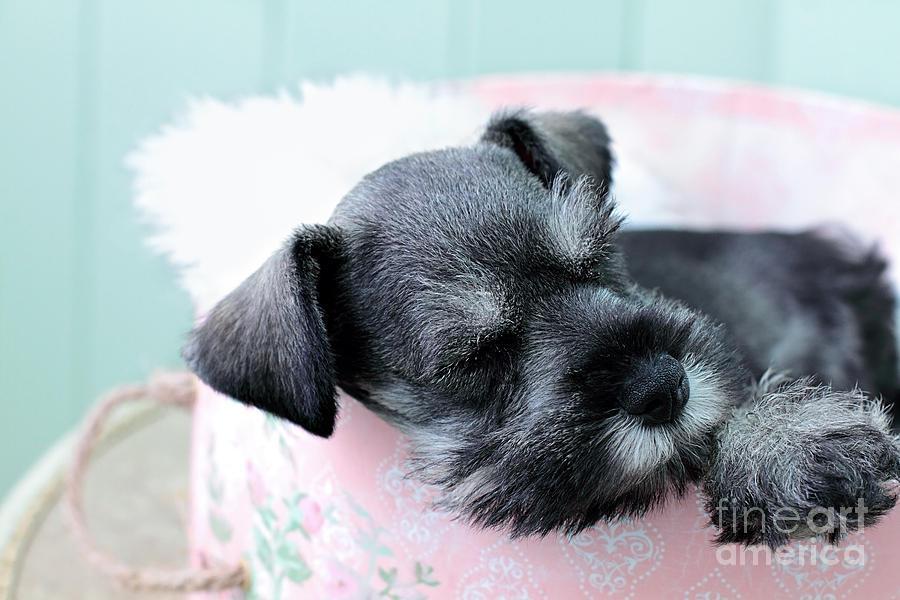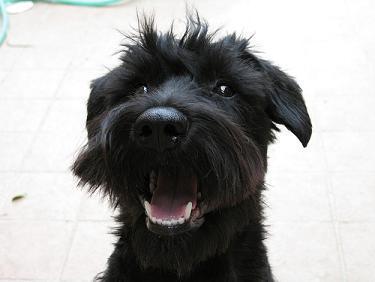The first image is the image on the left, the second image is the image on the right. For the images shown, is this caption "Each image contains exactly one schnauzer, and one image shows a schnauzer in some type of bed." true? Answer yes or no. Yes. 